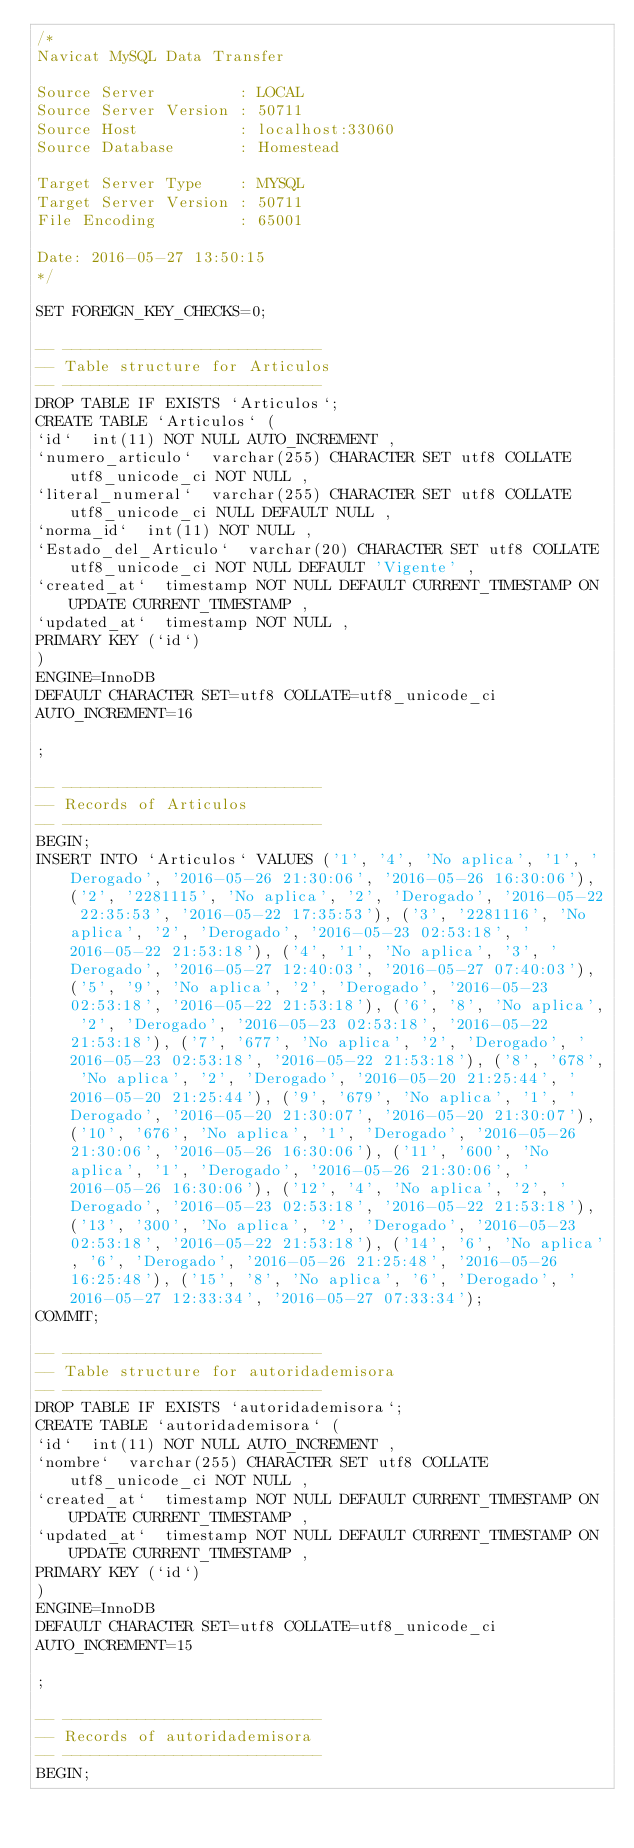<code> <loc_0><loc_0><loc_500><loc_500><_SQL_>/*
Navicat MySQL Data Transfer

Source Server         : LOCAL
Source Server Version : 50711
Source Host           : localhost:33060
Source Database       : Homestead

Target Server Type    : MYSQL
Target Server Version : 50711
File Encoding         : 65001

Date: 2016-05-27 13:50:15
*/

SET FOREIGN_KEY_CHECKS=0;

-- ----------------------------
-- Table structure for Articulos
-- ----------------------------
DROP TABLE IF EXISTS `Articulos`;
CREATE TABLE `Articulos` (
`id`  int(11) NOT NULL AUTO_INCREMENT ,
`numero_articulo`  varchar(255) CHARACTER SET utf8 COLLATE utf8_unicode_ci NOT NULL ,
`literal_numeral`  varchar(255) CHARACTER SET utf8 COLLATE utf8_unicode_ci NULL DEFAULT NULL ,
`norma_id`  int(11) NOT NULL ,
`Estado_del_Articulo`  varchar(20) CHARACTER SET utf8 COLLATE utf8_unicode_ci NOT NULL DEFAULT 'Vigente' ,
`created_at`  timestamp NOT NULL DEFAULT CURRENT_TIMESTAMP ON UPDATE CURRENT_TIMESTAMP ,
`updated_at`  timestamp NOT NULL ,
PRIMARY KEY (`id`)
)
ENGINE=InnoDB
DEFAULT CHARACTER SET=utf8 COLLATE=utf8_unicode_ci
AUTO_INCREMENT=16

;

-- ----------------------------
-- Records of Articulos
-- ----------------------------
BEGIN;
INSERT INTO `Articulos` VALUES ('1', '4', 'No aplica', '1', 'Derogado', '2016-05-26 21:30:06', '2016-05-26 16:30:06'), ('2', '2281115', 'No aplica', '2', 'Derogado', '2016-05-22 22:35:53', '2016-05-22 17:35:53'), ('3', '2281116', 'No aplica', '2', 'Derogado', '2016-05-23 02:53:18', '2016-05-22 21:53:18'), ('4', '1', 'No aplica', '3', 'Derogado', '2016-05-27 12:40:03', '2016-05-27 07:40:03'), ('5', '9', 'No aplica', '2', 'Derogado', '2016-05-23 02:53:18', '2016-05-22 21:53:18'), ('6', '8', 'No aplica', '2', 'Derogado', '2016-05-23 02:53:18', '2016-05-22 21:53:18'), ('7', '677', 'No aplica', '2', 'Derogado', '2016-05-23 02:53:18', '2016-05-22 21:53:18'), ('8', '678', 'No aplica', '2', 'Derogado', '2016-05-20 21:25:44', '2016-05-20 21:25:44'), ('9', '679', 'No aplica', '1', 'Derogado', '2016-05-20 21:30:07', '2016-05-20 21:30:07'), ('10', '676', 'No aplica', '1', 'Derogado', '2016-05-26 21:30:06', '2016-05-26 16:30:06'), ('11', '600', 'No aplica', '1', 'Derogado', '2016-05-26 21:30:06', '2016-05-26 16:30:06'), ('12', '4', 'No aplica', '2', 'Derogado', '2016-05-23 02:53:18', '2016-05-22 21:53:18'), ('13', '300', 'No aplica', '2', 'Derogado', '2016-05-23 02:53:18', '2016-05-22 21:53:18'), ('14', '6', 'No aplica', '6', 'Derogado', '2016-05-26 21:25:48', '2016-05-26 16:25:48'), ('15', '8', 'No aplica', '6', 'Derogado', '2016-05-27 12:33:34', '2016-05-27 07:33:34');
COMMIT;

-- ----------------------------
-- Table structure for autoridademisora
-- ----------------------------
DROP TABLE IF EXISTS `autoridademisora`;
CREATE TABLE `autoridademisora` (
`id`  int(11) NOT NULL AUTO_INCREMENT ,
`nombre`  varchar(255) CHARACTER SET utf8 COLLATE utf8_unicode_ci NOT NULL ,
`created_at`  timestamp NOT NULL DEFAULT CURRENT_TIMESTAMP ON UPDATE CURRENT_TIMESTAMP ,
`updated_at`  timestamp NOT NULL DEFAULT CURRENT_TIMESTAMP ON UPDATE CURRENT_TIMESTAMP ,
PRIMARY KEY (`id`)
)
ENGINE=InnoDB
DEFAULT CHARACTER SET=utf8 COLLATE=utf8_unicode_ci
AUTO_INCREMENT=15

;

-- ----------------------------
-- Records of autoridademisora
-- ----------------------------
BEGIN;</code> 